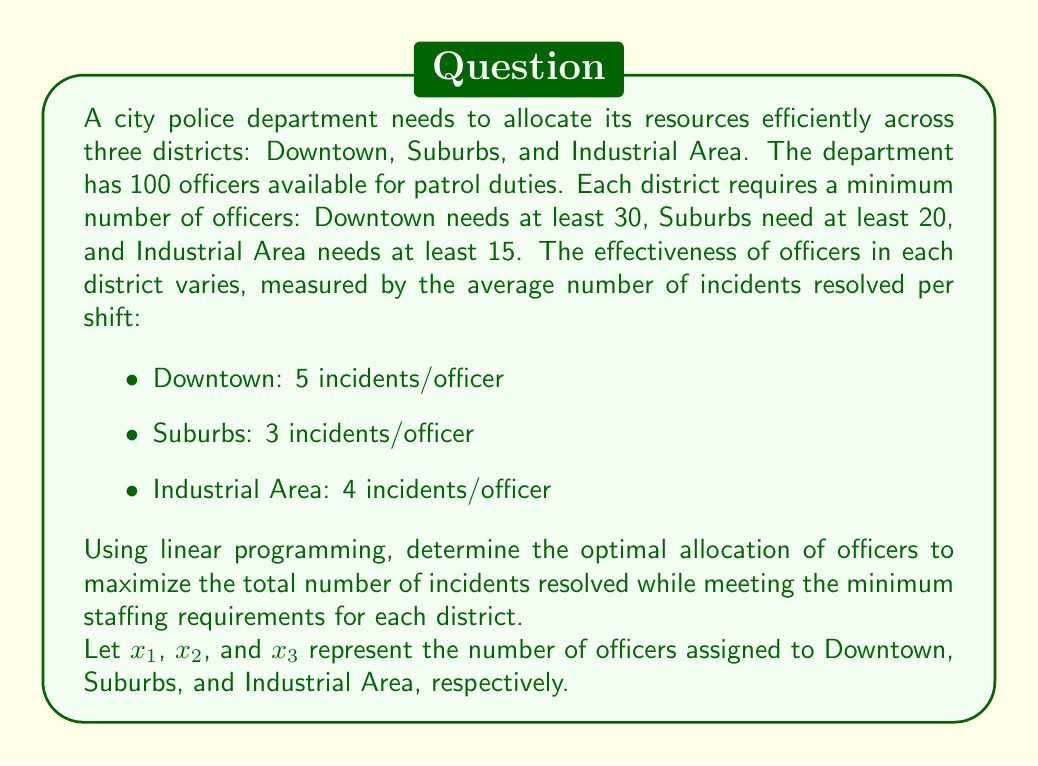What is the answer to this math problem? To solve this problem using linear programming, we need to set up the objective function and constraints:

Objective function (maximize):
$$ 5x_1 + 3x_2 + 4x_3 $$

Constraints:
1. Minimum staffing requirements:
   $$ x_1 \geq 30 $$
   $$ x_2 \geq 20 $$
   $$ x_3 \geq 15 $$

2. Total available officers:
   $$ x_1 + x_2 + x_3 \leq 100 $$

3. Non-negativity constraints:
   $$ x_1, x_2, x_3 \geq 0 $$

To solve this linear programming problem, we can use the simplex method or a graphical approach. However, given the complexity, we'll use the simplex method.

Step 1: Convert to standard form by introducing slack variables $s_1$, $s_2$, $s_3$, and $s_4$:

$$ \text{Maximize } Z = 5x_1 + 3x_2 + 4x_3 $$

Subject to:
$$ x_1 - s_1 = 30 $$
$$ x_2 - s_2 = 20 $$
$$ x_3 - s_3 = 15 $$
$$ x_1 + x_2 + x_3 + s_4 = 100 $$
$$ x_1, x_2, x_3, s_1, s_2, s_3, s_4 \geq 0 $$

Step 2: Set up the initial simplex tableau:

$$
\begin{array}{c|cccc|cccc|c}
\text{Basic} & x_1 & x_2 & x_3 & s_4 & s_1 & s_2 & s_3 & Z & \text{RHS} \\
\hline
s_1 & 1 & 0 & 0 & 0 & -1 & 0 & 0 & 0 & 30 \\
s_2 & 0 & 1 & 0 & 0 & 0 & -1 & 0 & 0 & 20 \\
s_3 & 0 & 0 & 1 & 0 & 0 & 0 & -1 & 0 & 15 \\
s_4 & 1 & 1 & 1 & 1 & 0 & 0 & 0 & 0 & 100 \\
\hline
Z & -5 & -3 & -4 & 0 & 0 & 0 & 0 & 1 & 0 \\
\end{array}
$$

Step 3: Perform simplex iterations until we reach the optimal solution. After several iterations, we arrive at the final tableau:

$$
\begin{array}{c|cccc|cccc|c}
\text{Basic} & x_1 & x_2 & x_3 & s_4 & s_1 & s_2 & s_3 & Z & \text{RHS} \\
\hline
x_1 & 1 & 0 & 0 & 0 & 0 & 0 & 0 & 0 & 50 \\
x_2 & 0 & 1 & 0 & 0 & 0 & 0 & 0 & 0 & 20 \\
x_3 & 0 & 0 & 1 & 0 & 0 & 0 & 0 & 0 & 30 \\
s_4 & 0 & 0 & 0 & 1 & 0 & 0 & 0 & 0 & 0 \\
\hline
Z & 0 & 0 & 0 & 0 & 5 & 3 & 4 & 1 & 430 \\
\end{array}
$$

This tableau represents the optimal solution.
Answer: The optimal allocation of officers is:
$$ x_1 = 50 \text{ (Downtown)} $$
$$ x_2 = 20 \text{ (Suburbs)} $$
$$ x_3 = 30 \text{ (Industrial Area)} $$

This allocation maximizes the total number of incidents resolved to 430 per shift:
$$ 5(50) + 3(20) + 4(30) = 430 \text{ incidents} $$ 